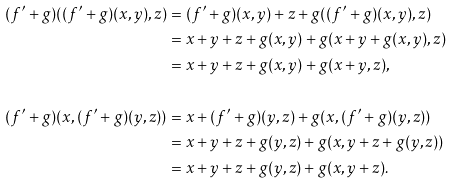<formula> <loc_0><loc_0><loc_500><loc_500>( f ^ { \prime } + g ) ( ( f ^ { \prime } + g ) ( x , y ) , z ) & = ( f ^ { \prime } + g ) ( x , y ) + z + g ( ( f ^ { \prime } + g ) ( x , y ) , z ) \\ & = x + y + z + g ( x , y ) + g ( x + y + g ( x , y ) , z ) \\ & = x + y + z + g ( x , y ) + g ( x + y , z ) , \\ \\ ( f ^ { \prime } + g ) ( x , ( f ^ { \prime } + g ) ( y , z ) ) & = x + ( f ^ { \prime } + g ) ( y , z ) + g ( x , ( f ^ { \prime } + g ) ( y , z ) ) \\ & = x + y + z + g ( y , z ) + g ( x , y + z + g ( y , z ) ) \\ & = x + y + z + g ( y , z ) + g ( x , y + z ) .</formula> 